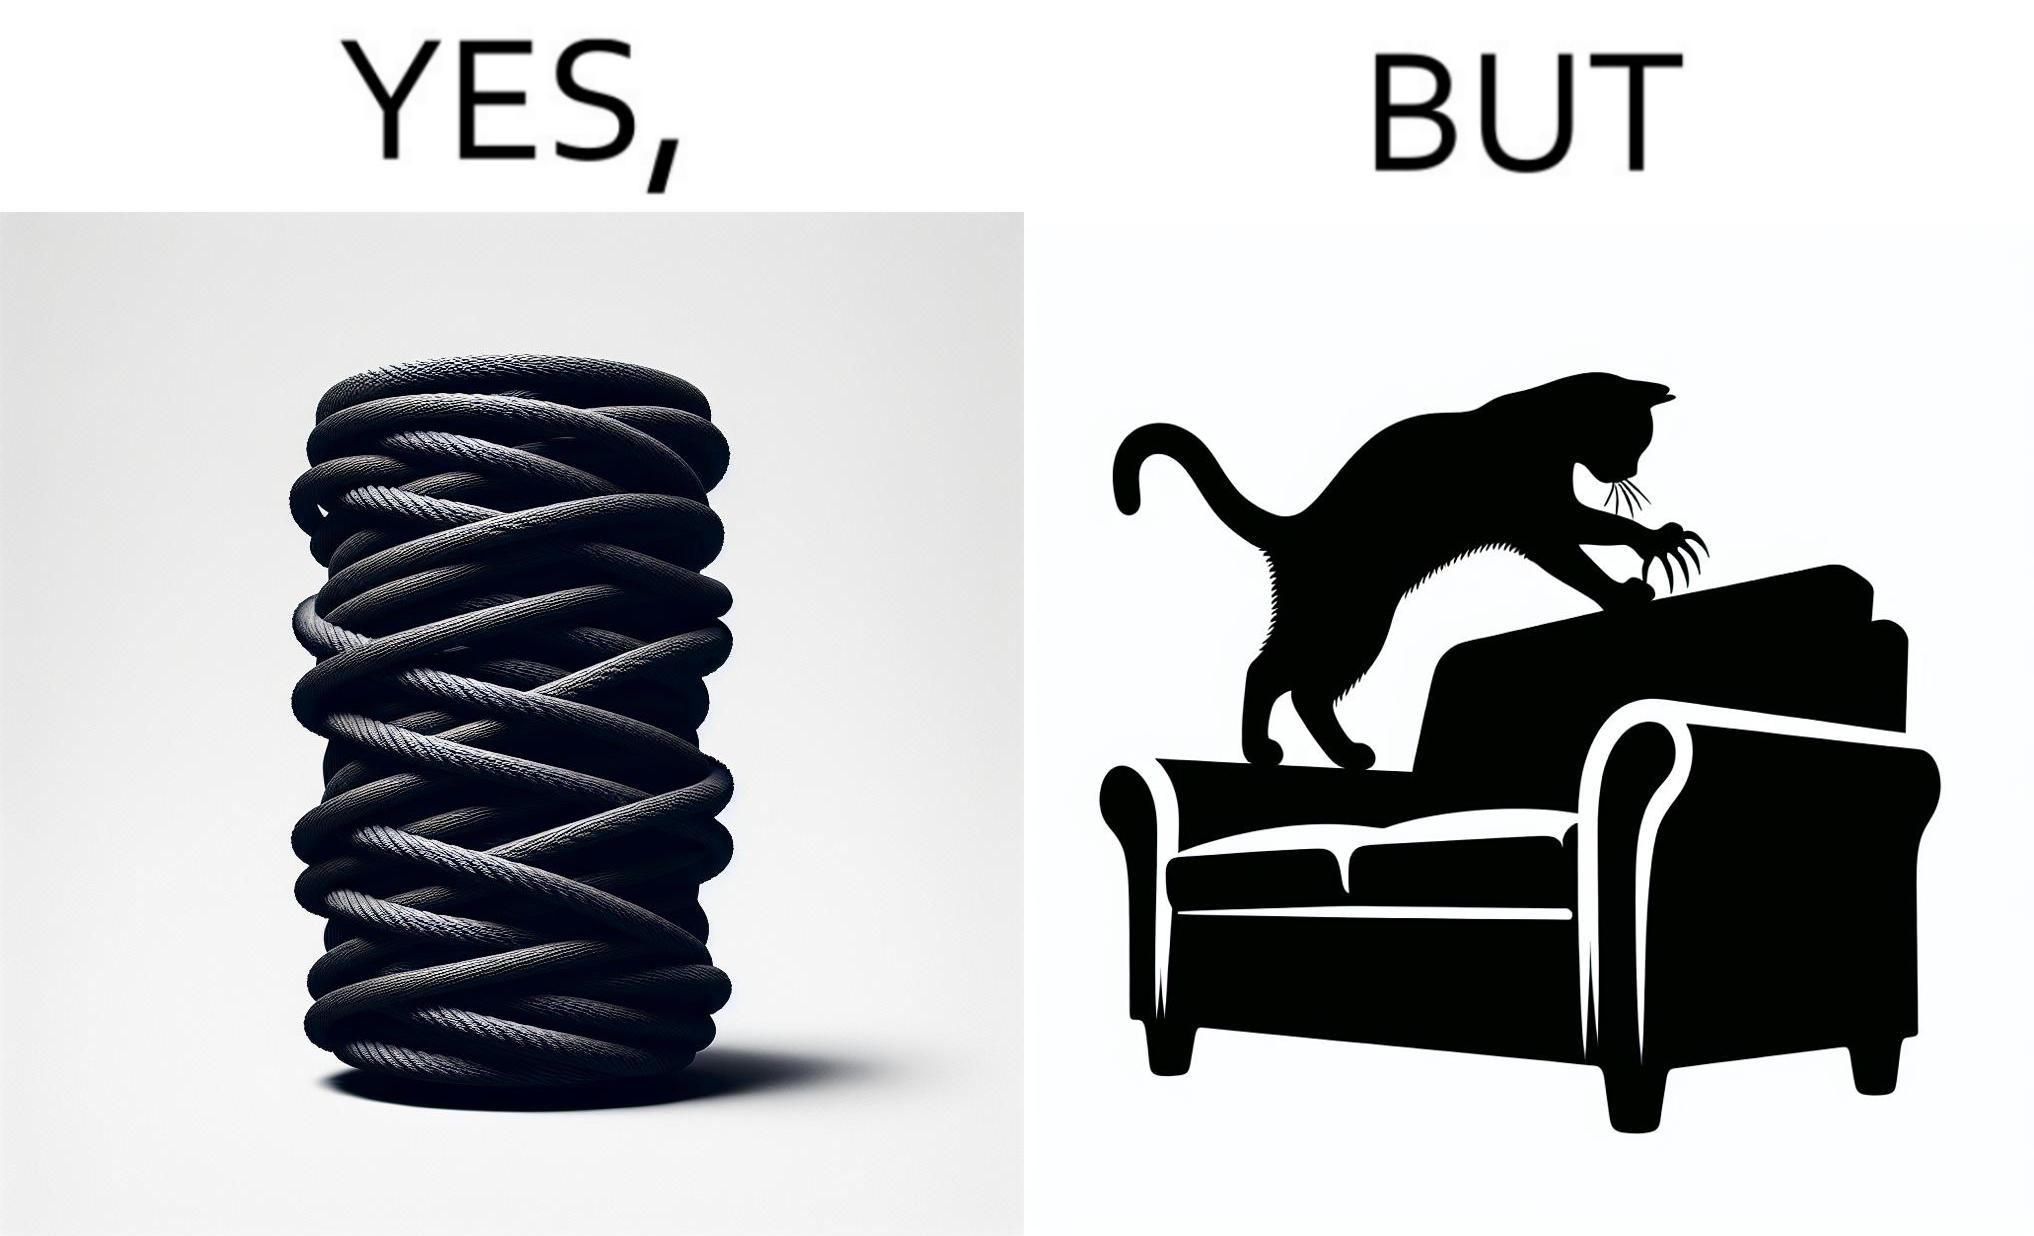Is there satirical content in this image? Yes, this image is satirical. 